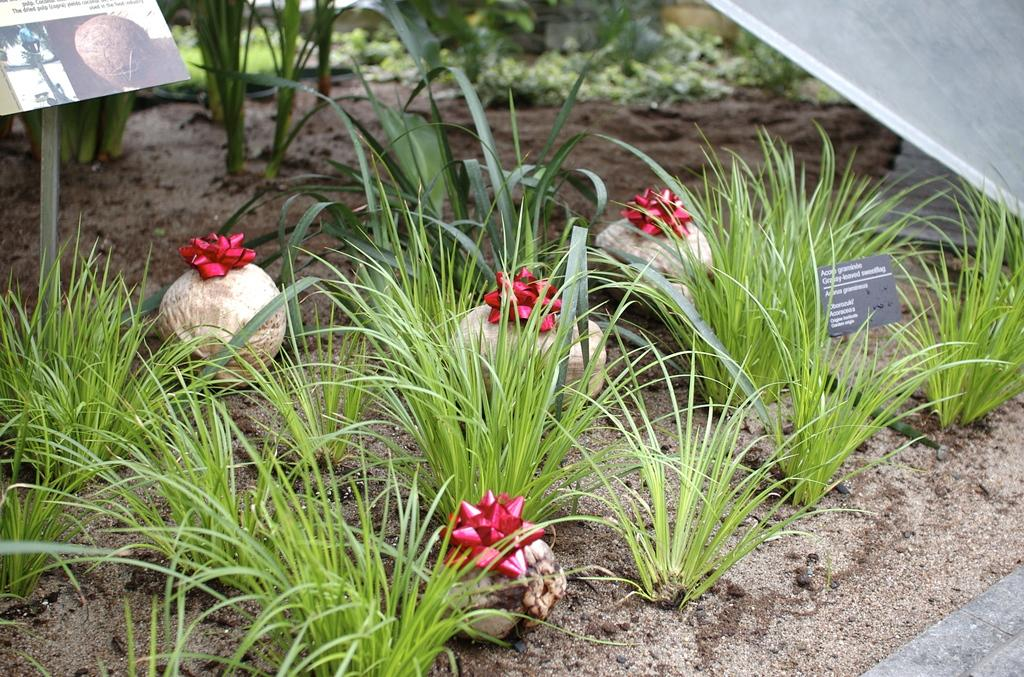What can be seen on the path in the image? There are plants on the path in the image. What else is visible in the image besides the plants? There are items visible in the image, including boards, a stand, and an object on the right side of the plants. What is the purpose of the boards behind the plants? The boards behind the plants may serve as a backdrop or support for the plants. What is the stand behind the plants used for? The stand behind the plants may be used to hold or display the plants. Can you tell me how many friends the judge has in the image? There is no judge or friends present in the image; it features plants on a path with various items in the background. 